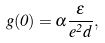<formula> <loc_0><loc_0><loc_500><loc_500>g ( 0 ) = \alpha \frac { \varepsilon } { e ^ { 2 } d } ,</formula> 